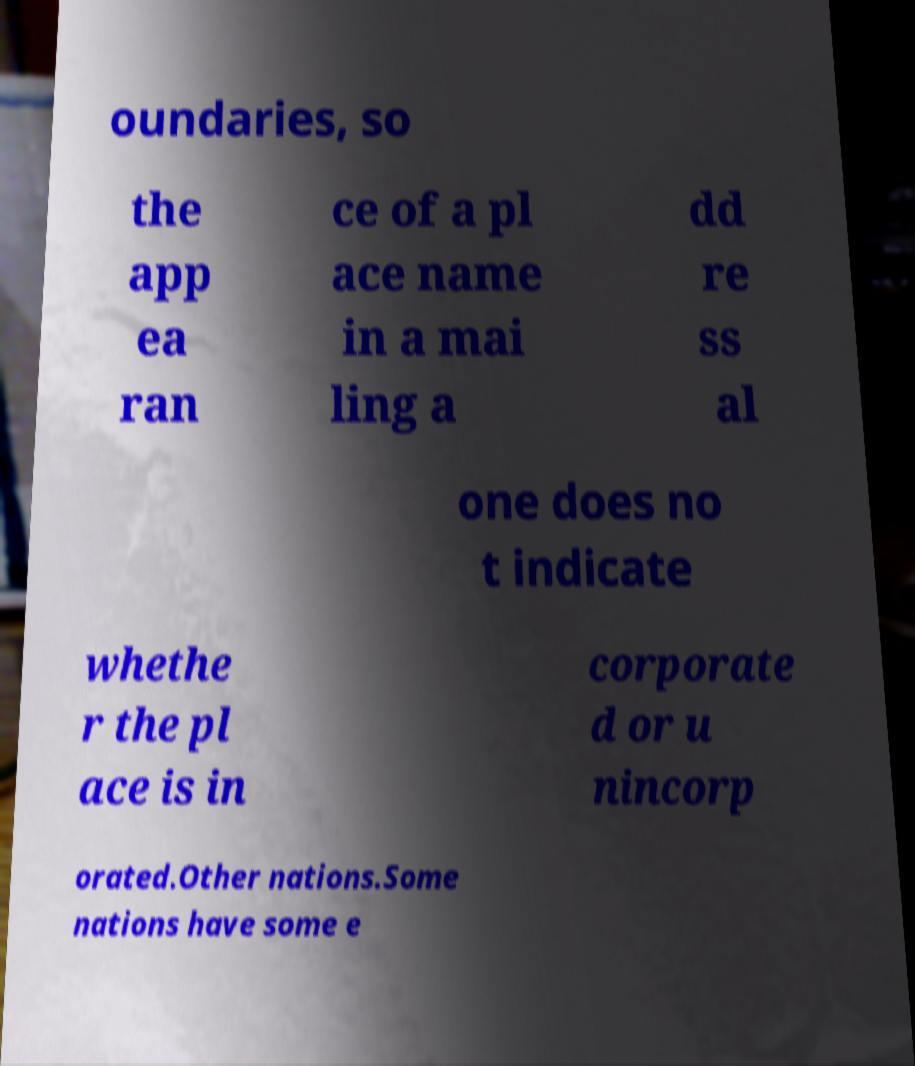I need the written content from this picture converted into text. Can you do that? oundaries, so the app ea ran ce of a pl ace name in a mai ling a dd re ss al one does no t indicate whethe r the pl ace is in corporate d or u nincorp orated.Other nations.Some nations have some e 